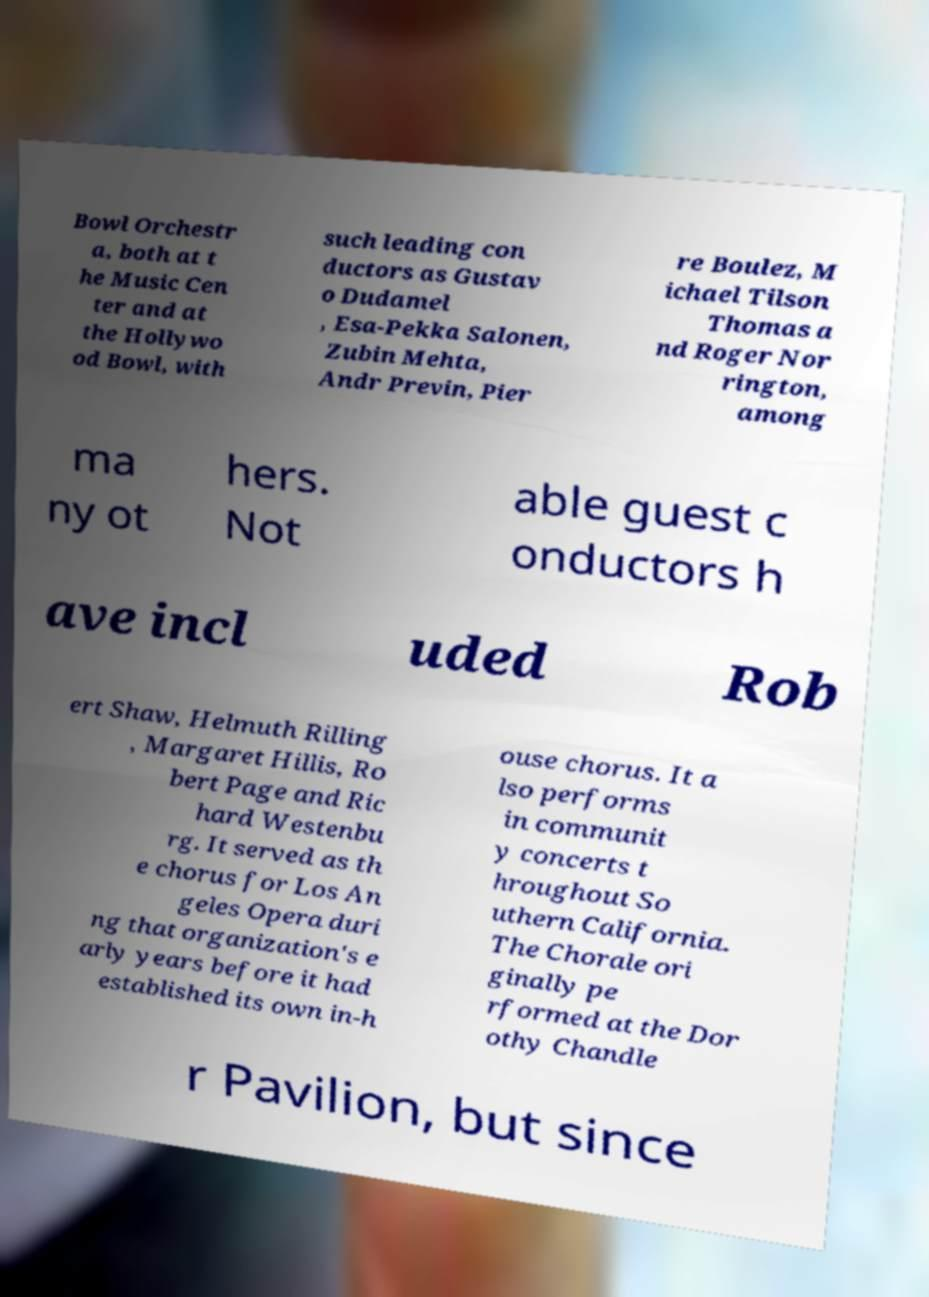Can you read and provide the text displayed in the image?This photo seems to have some interesting text. Can you extract and type it out for me? Bowl Orchestr a, both at t he Music Cen ter and at the Hollywo od Bowl, with such leading con ductors as Gustav o Dudamel , Esa-Pekka Salonen, Zubin Mehta, Andr Previn, Pier re Boulez, M ichael Tilson Thomas a nd Roger Nor rington, among ma ny ot hers. Not able guest c onductors h ave incl uded Rob ert Shaw, Helmuth Rilling , Margaret Hillis, Ro bert Page and Ric hard Westenbu rg. It served as th e chorus for Los An geles Opera duri ng that organization's e arly years before it had established its own in-h ouse chorus. It a lso performs in communit y concerts t hroughout So uthern California. The Chorale ori ginally pe rformed at the Dor othy Chandle r Pavilion, but since 